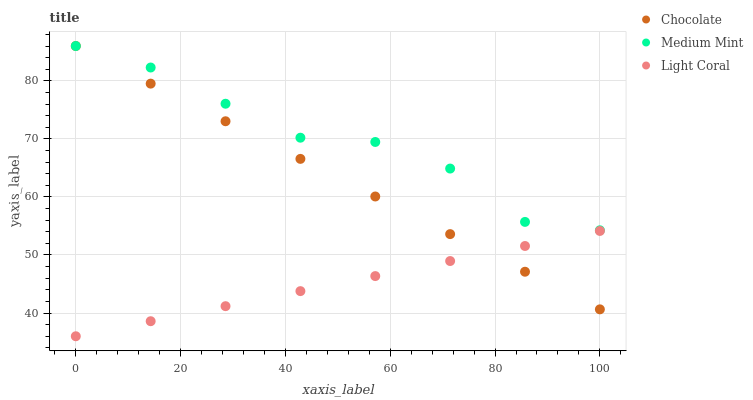Does Light Coral have the minimum area under the curve?
Answer yes or no. Yes. Does Medium Mint have the maximum area under the curve?
Answer yes or no. Yes. Does Chocolate have the minimum area under the curve?
Answer yes or no. No. Does Chocolate have the maximum area under the curve?
Answer yes or no. No. Is Light Coral the smoothest?
Answer yes or no. Yes. Is Medium Mint the roughest?
Answer yes or no. Yes. Is Chocolate the smoothest?
Answer yes or no. No. Is Chocolate the roughest?
Answer yes or no. No. Does Light Coral have the lowest value?
Answer yes or no. Yes. Does Chocolate have the lowest value?
Answer yes or no. No. Does Chocolate have the highest value?
Answer yes or no. Yes. Does Light Coral have the highest value?
Answer yes or no. No. Is Light Coral less than Medium Mint?
Answer yes or no. Yes. Is Medium Mint greater than Light Coral?
Answer yes or no. Yes. Does Medium Mint intersect Chocolate?
Answer yes or no. Yes. Is Medium Mint less than Chocolate?
Answer yes or no. No. Is Medium Mint greater than Chocolate?
Answer yes or no. No. Does Light Coral intersect Medium Mint?
Answer yes or no. No. 